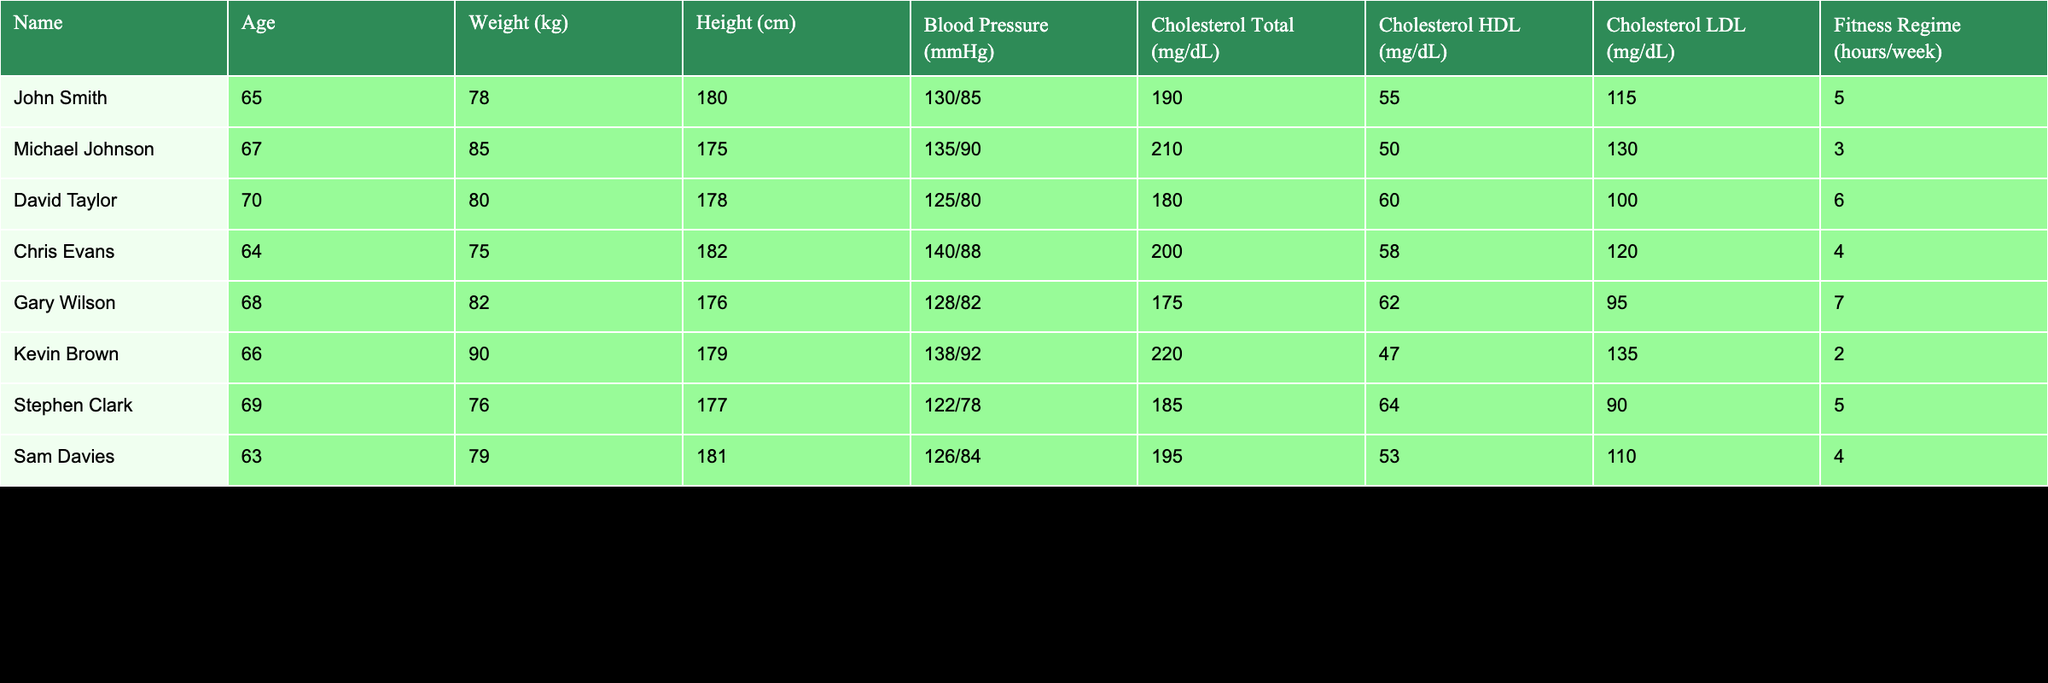What is the blood pressure of John Smith? The blood pressure of John Smith is listed in the table as "130/85".
Answer: 130/85 Which athlete has the highest cholesterol total? By scanning through the Cholesterol Total column, we find that Kevin Brown has the highest value at 220 mg/dL.
Answer: 220 mg/dL What is the average weight of the athletes in the table? To find the average weight, we add the weights of all athletes (78 + 85 + 80 + 75 + 82 + 90 + 76 + 79) =  644 kg, then divide by the number of athletes (8): 644/8 = 80.5 kg.
Answer: 80.5 kg Is David Taylor's HDL cholesterol higher than Michael Johnson's? David Taylor's HDL is 60 mg/dL, while Michael Johnson's HDL is 50 mg/dL. Since 60 is greater than 50, the answer is yes.
Answer: Yes What is the average fitness regime hours for athletes with a blood pressure lower than 130/85? The athletes with blood pressure lower than 130/85 are David Taylor, Stephen Clark, and Sam Davies. Their fitness regime hours are 6, 5, and 4, respectively. The average is (6 + 5 + 4)/3 = 5 hours.
Answer: 5 hours Which athlete has the lowest LDL cholesterol? By checking the Cholesterol LDL column, we see that Gary Wilson has the lowest value at 95 mg/dL.
Answer: 95 mg/dL Do any athletes have a cholesterol HDL level higher than 60 mg/dL? Yes, both David Taylor (60) and Stephen Clark (64) have HDL levels equal to or above 60 mg/dL.
Answer: Yes What is the difference in blood pressure between Gary Wilson and Kevin Brown? Gary Wilson's blood pressure is 128/82 and Kevin Brown's is 138/92. The systolic difference is 138 - 128 = 10 mmHg, and the diastolic difference is 92 - 82 = 10 mmHg.
Answer: 10/10 mmHg 